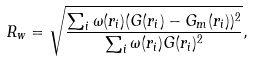<formula> <loc_0><loc_0><loc_500><loc_500>R _ { w } = \sqrt { \frac { \sum _ { i } \omega ( r _ { i } ) ( G ( r _ { i } ) - G _ { m } ( r _ { i } ) ) ^ { 2 } } { \sum _ { i } \omega ( r _ { i } ) G ( r _ { i } ) ^ { 2 } } } ,</formula> 